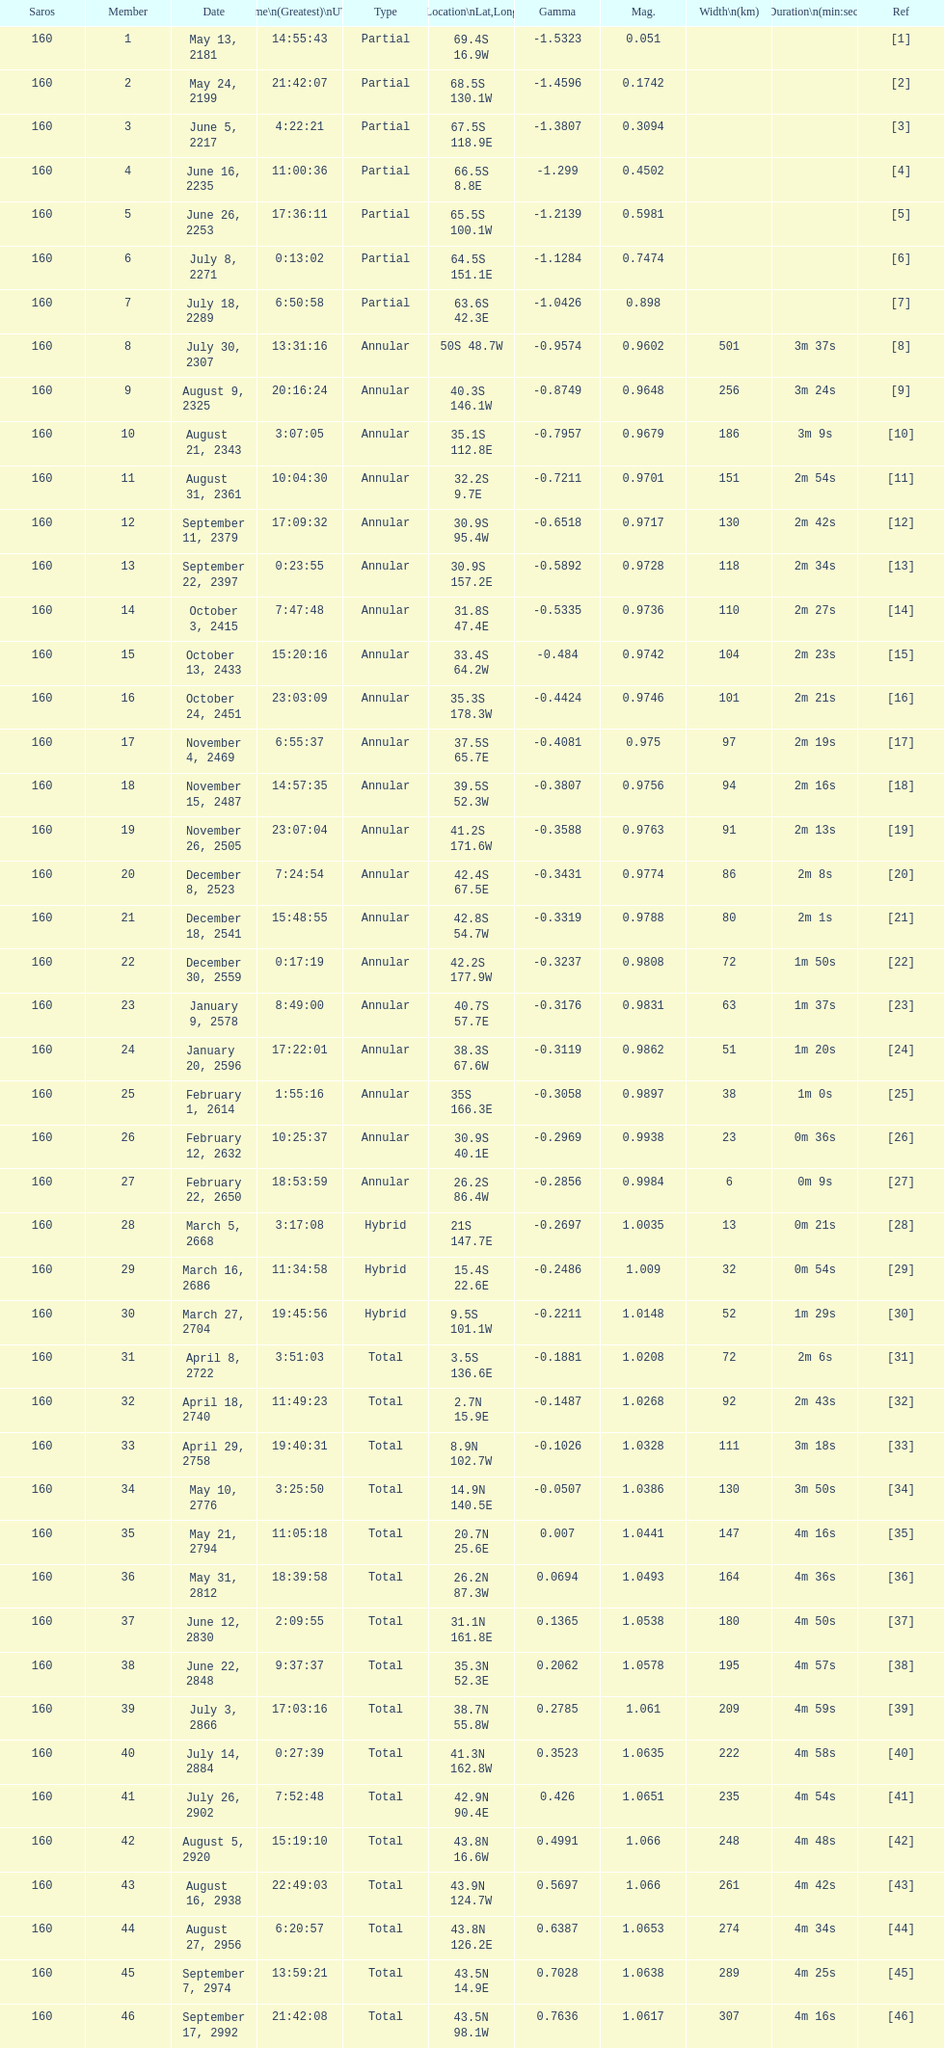How many total events will occur in all? 46. 